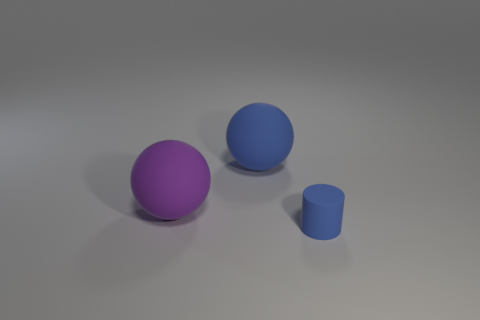Can you describe the lighting in the image? The image features soft, diffused lighting, likely from an overhead source, creating gentle shadows under the objects, which gives the scene a calm and evenly illuminated appearance. 